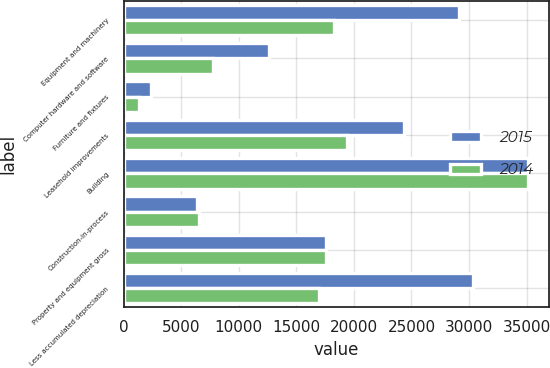<chart> <loc_0><loc_0><loc_500><loc_500><stacked_bar_chart><ecel><fcel>Equipment and machinery<fcel>Computer hardware and software<fcel>Furniture and fixtures<fcel>Leasehold improvements<fcel>Building<fcel>Construction-in-process<fcel>Property and equipment gross<fcel>Less accumulated depreciation<nl><fcel>2015<fcel>29101<fcel>12630<fcel>2380<fcel>24372<fcel>35154<fcel>6408<fcel>17611.5<fcel>30339<nl><fcel>2014<fcel>18265<fcel>7772<fcel>1373<fcel>19420<fcel>35154<fcel>6532<fcel>17611.5<fcel>16958<nl></chart> 